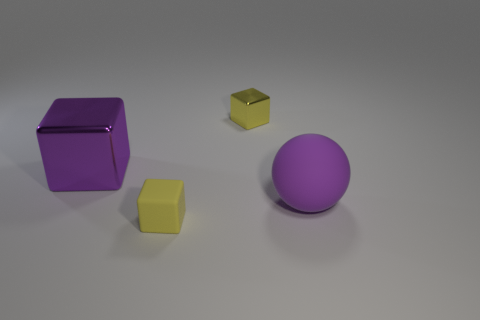Is there anything else that is the same size as the purple rubber sphere?
Your answer should be very brief. Yes. How many other cubes have the same color as the matte block?
Keep it short and to the point. 1. How many tiny yellow matte cylinders are there?
Your answer should be compact. 0. What number of cubes are the same material as the ball?
Keep it short and to the point. 1. There is another yellow shiny object that is the same shape as the large shiny object; what size is it?
Your answer should be very brief. Small. What is the ball made of?
Your answer should be very brief. Rubber. There is a purple thing that is on the right side of the metallic cube that is behind the purple thing behind the rubber ball; what is its material?
Provide a short and direct response. Rubber. Is there anything else that has the same shape as the big purple matte object?
Your answer should be very brief. No. What color is the big object that is the same shape as the tiny metallic object?
Provide a succinct answer. Purple. Do the tiny block to the left of the yellow shiny object and the metallic object that is on the left side of the small yellow metal thing have the same color?
Give a very brief answer. No. 